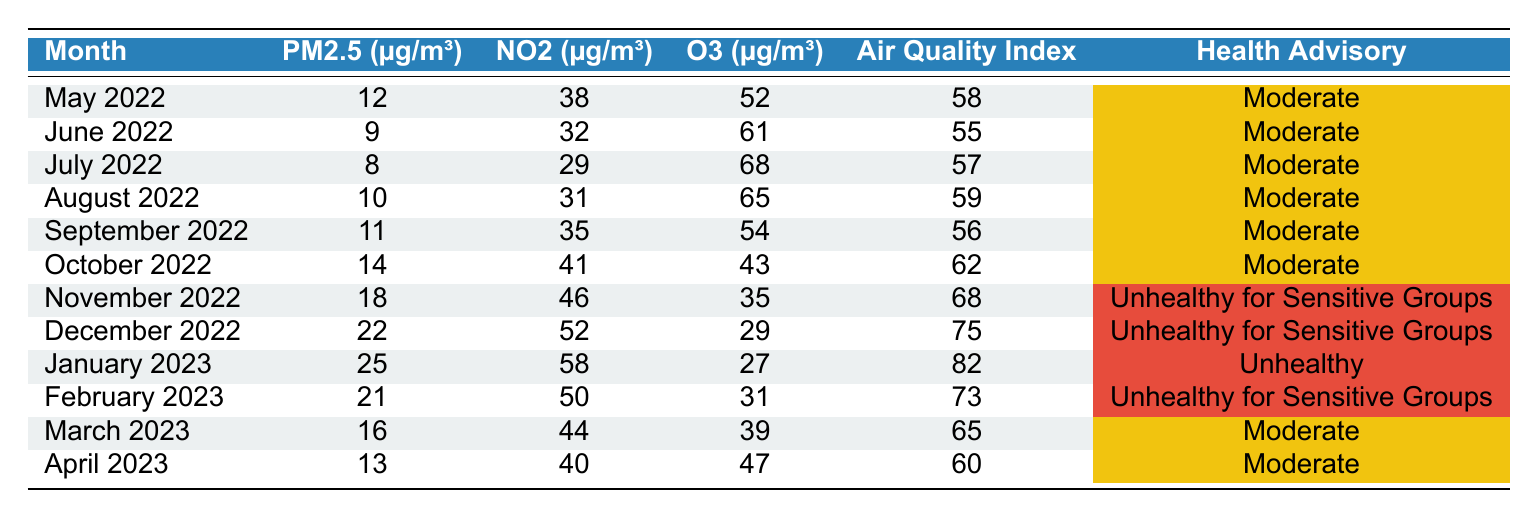What was the highest PM2.5 reading recorded in the past year? The highest PM2.5 reading was 25 µg/m³ in January 2023. This was found by scanning through the PM2.5 values listed for each month and identifying that January 2023 had the highest value.
Answer: 25 µg/m³ In which month did the Air Quality Index classify the air quality as "Unhealthy"? The Air Quality Index classified the air quality as "Unhealthy" in January 2023, which is clearly marked in the table under the respective month.
Answer: January 2023 What is the average NO2 level over the past year? To calculate the average NO2 level, sum all the NO2 values: (38 + 32 + 29 + 31 + 35 + 41 + 46 + 52 + 58 + 50 + 44 + 40) =  434. There are 12 months, so the average is 434/12 = 36.17 µg/m³.
Answer: 36.17 µg/m³ Was there a month when the Air Quality Index was classified as "Unhealthy for Sensitive Groups" and also had NO2 levels above 50 µg/m³? Yes, November 2022 and December 2022 were both classified as "Unhealthy for Sensitive Groups" and had NO2 levels of 46 µg/m³ and 52 µg/m³ respectively. Therefore, December meets the criteria of having NO2 above 50 µg/m³.
Answer: Yes Which month had the lowest O3 level, and what was that level? The lowest O3 level was found in December 2022, with a value of 29 µg/m³. By checking each month's O3 value, December is identified as the one with the lowest reading.
Answer: December 2022, 29 µg/m³ How does the Air Quality Index change from November 2022 to April 2023? The Air Quality Index worsened from November 2022 (Unhealthy for Sensitive Groups) to January 2023 (Unhealthy), then improved back to Moderate in March and April 2023. This requires looking at the AQI classifications for each of those months.
Answer: Worsened then improved What is the overall trend in NO2 levels from May 2022 to April 2023? The trend shows an increase in NO2 levels from May 2022 (38 µg/m³) to January 2023 (58 µg/m³) and a slight decrease in February to April 2023, indicating a peak in January followed by a decline. This is determined by comparing NO2 values month by month.
Answer: Increase then slight decrease In how many months was the air quality rated as "Moderate"? The air quality was rated as "Moderate" in 6 months: May, June, July, August, September 2022, and March, April 2023. Count each month labeled as "Moderate" in the table to get this total.
Answer: 6 months What was the difference in PM2.5 levels between January 2023 and the month with the lowest PM2.5? In January 2023, PM2.5 was 25 µg/m³, and the lowest PM2.5 recorded was 8 µg/m³ in July 2022. Therefore, the difference is 25 - 8 = 17 µg/m³. To find the difference, subtract the lowest value from January's value.
Answer: 17 µg/m³ Which month had both an O3 level above 60 µg/m³ and an Air Quality Index of "Moderate"? Both June 2022 (O3 level 61 µg/m³) and August 2022 (O3 level 65 µg/m³) had O3 levels above 60 µg/m³ with an Air Quality Index of "Moderate." This involves checking the O3 levels and AQI for each month.
Answer: June and August 2022 Was the PM2.5 level higher in December 2022 than in April 2023? Yes, December 2022 had a PM2.5 level of 22 µg/m³, which is higher than April 2023's PM2.5 level of 13 µg/m³. This requires comparing the PM2.5 values for both months.
Answer: Yes 